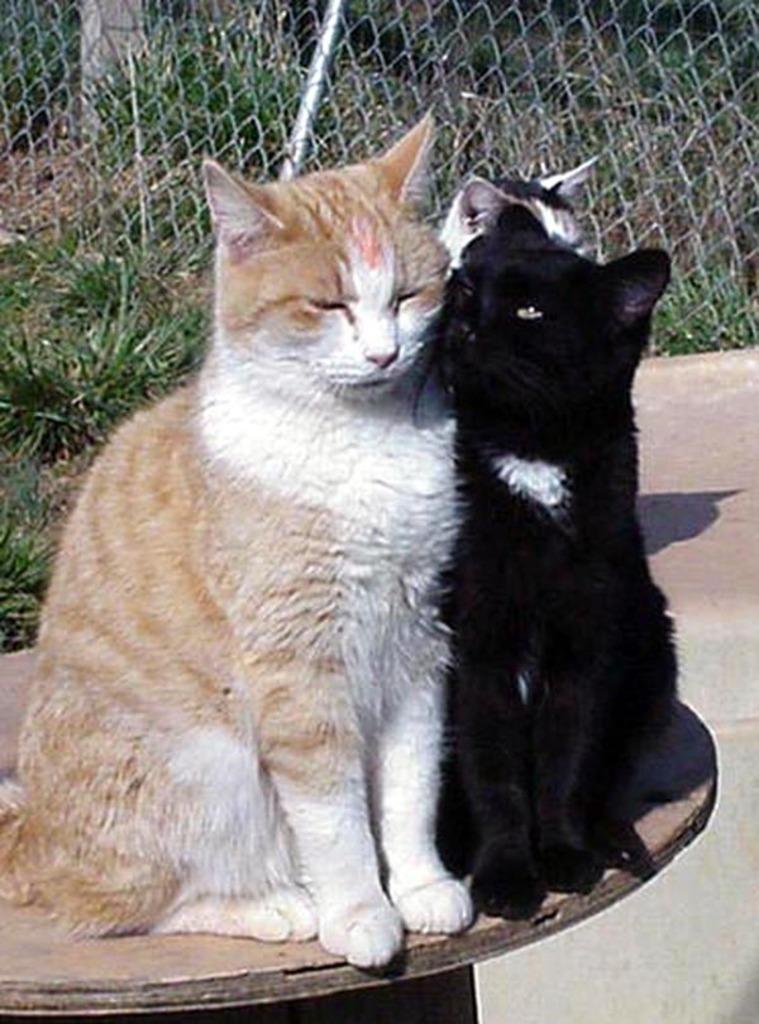In one or two sentences, can you explain what this image depicts? In this picture there are three cats sitting on the table. At the back there is a fence and there are plants behind the fence. At the bottom there is a floor. 